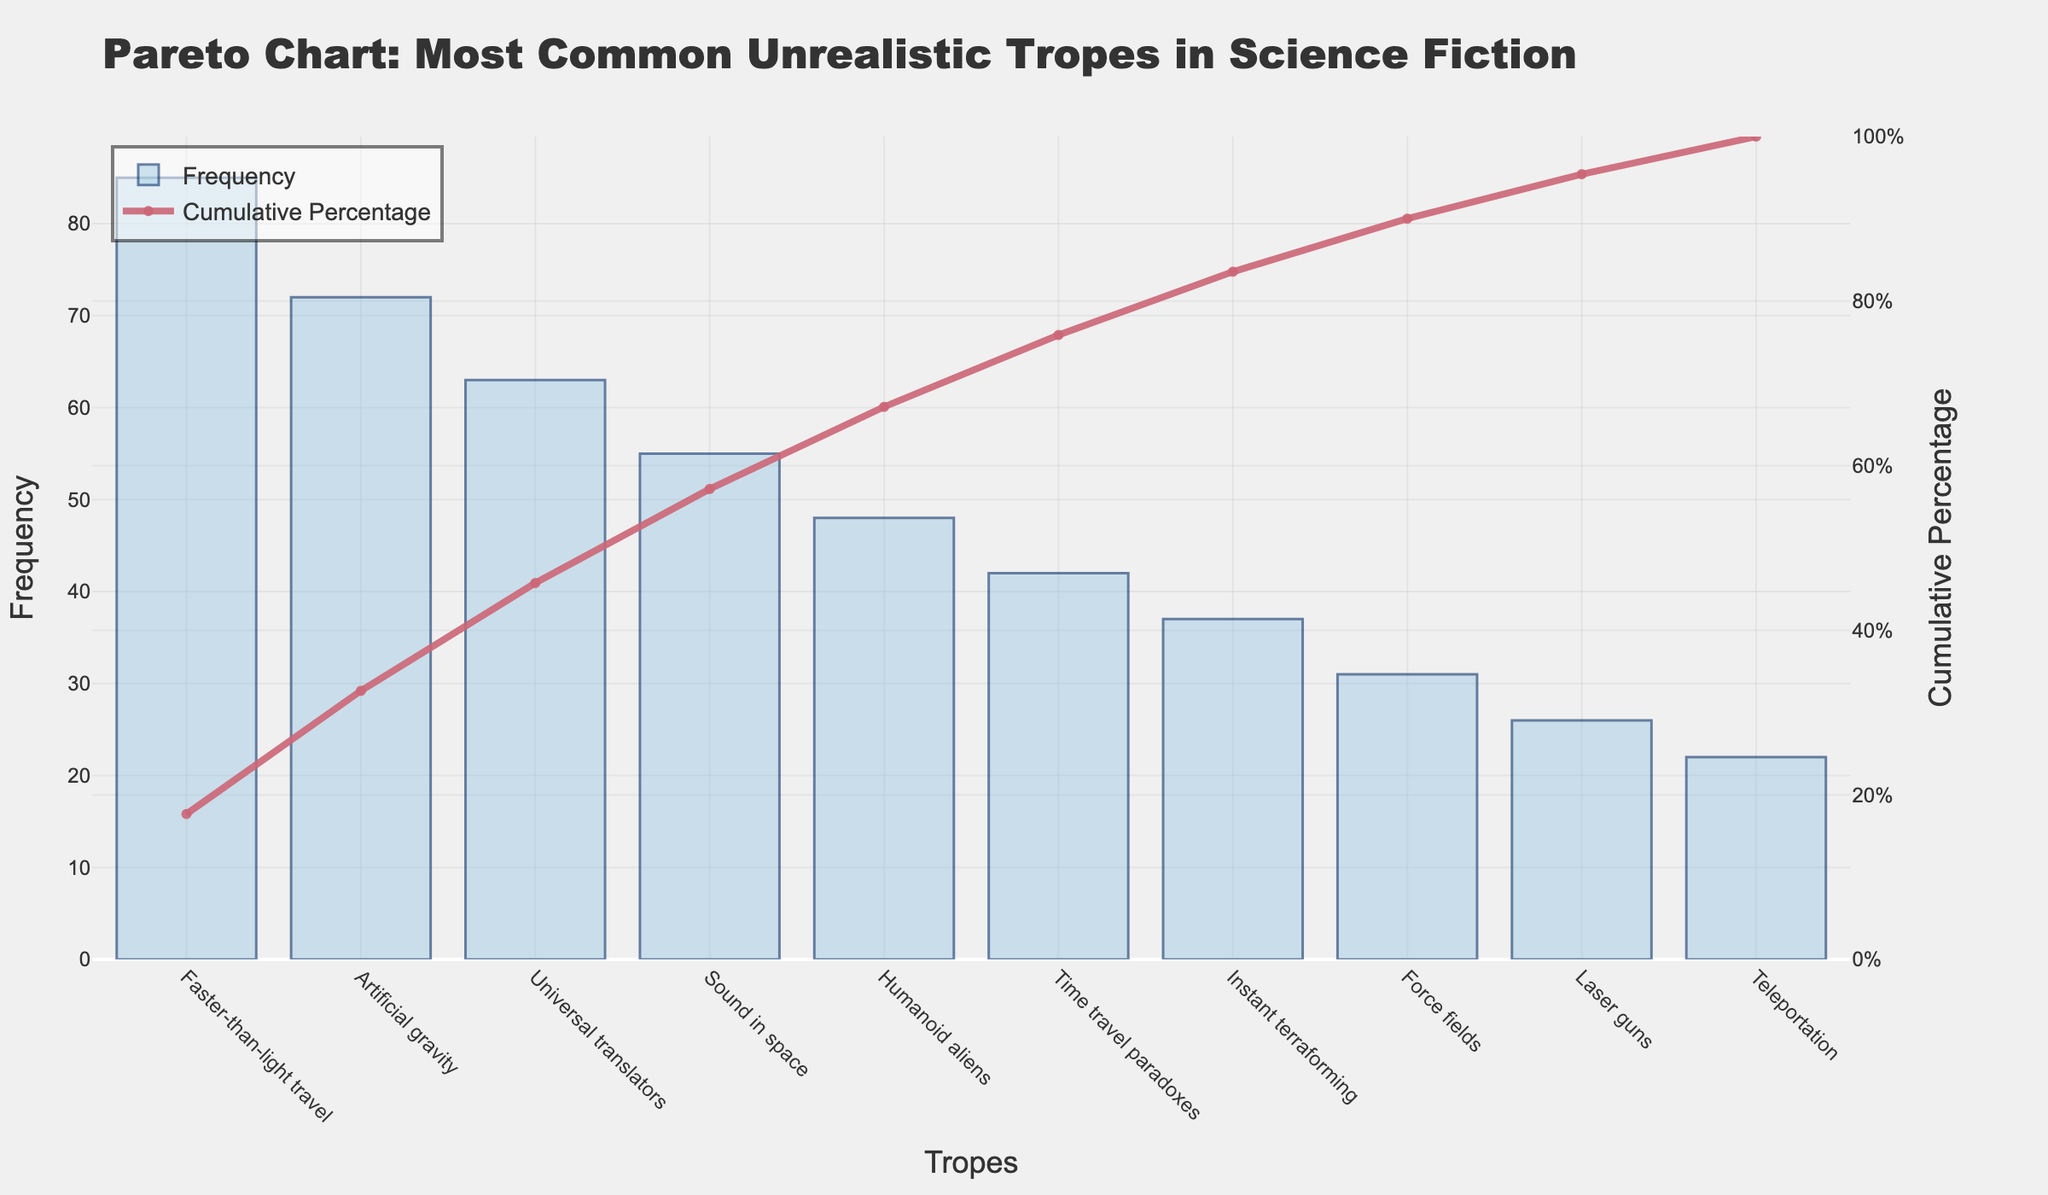What is the title of the chart? The title of the chart is displayed at the top and reads "Pareto Chart: Most Common Unrealistic Tropes in Science Fiction".
Answer: Pareto Chart: Most Common Unrealistic Tropes in Science Fiction How many unrealistic tropes are included in the chart? By counting the bars on the x-axis, we can see that there are 10 unrealistic tropes included in the chart.
Answer: 10 Which trope has the highest frequency? The tallest bar on the chart corresponds to "Faster-than-light travel," indicating it has the highest frequency.
Answer: Faster-than-light travel What is the frequency of the least common trope? The shortest bar on the chart corresponds to "Teleportation," indicating it has a frequency of 22.
Answer: 22 What percentage of cumulative frequency is reached with "Humanoid aliens"? By following the cumulative percentage line up to "Humanoid aliens," we see that it reaches approximately 73%.
Answer: 73% How many tropes contribute to about 50% of the total frequency? The cumulative percentage line reaches around 50% just after "Universal translators," which is the third trope. So, three tropes contribute to about 50% of the total frequency.
Answer: 3 What is the combined frequency of "Force fields" and "Laser guns"? Adding the frequencies of "Force fields" (31) and "Laser guns" (26), the combined frequency is 31 + 26 = 57.
Answer: 57 Is "Time travel paradoxes" more common than "Humanoid aliens"? Comparing the heights of the bars for "Time travel paradoxes" (42) and "Humanoid aliens" (48), we see that "Humanoid aliens" is more common.
Answer: No What trope marks the point where the cumulative percentage exceeds 90%? Following the cumulative percentage line, we see that it exceeds 90% just after "Force fields."
Answer: Force fields How many tropes have a frequency greater than 50? Counting the bars with heights above 50 shows that there are four tropes: "Faster-than-light travel," "Artificial gravity," "Universal translators," and "Sound in space."
Answer: 4 